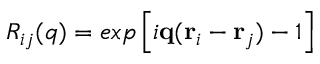Convert formula to latex. <formula><loc_0><loc_0><loc_500><loc_500>R _ { i j } ( q ) = e x p \left [ i \mathbf q ( \mathbf r _ { i } - \mathbf r _ { j } ) - 1 \right ]</formula> 